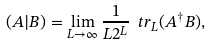<formula> <loc_0><loc_0><loc_500><loc_500>( A | B ) = \lim _ { L \rightarrow \infty } \frac { 1 } { L 2 ^ { L } } \ t r _ { L } ( A ^ { \dagger } B ) ,</formula> 